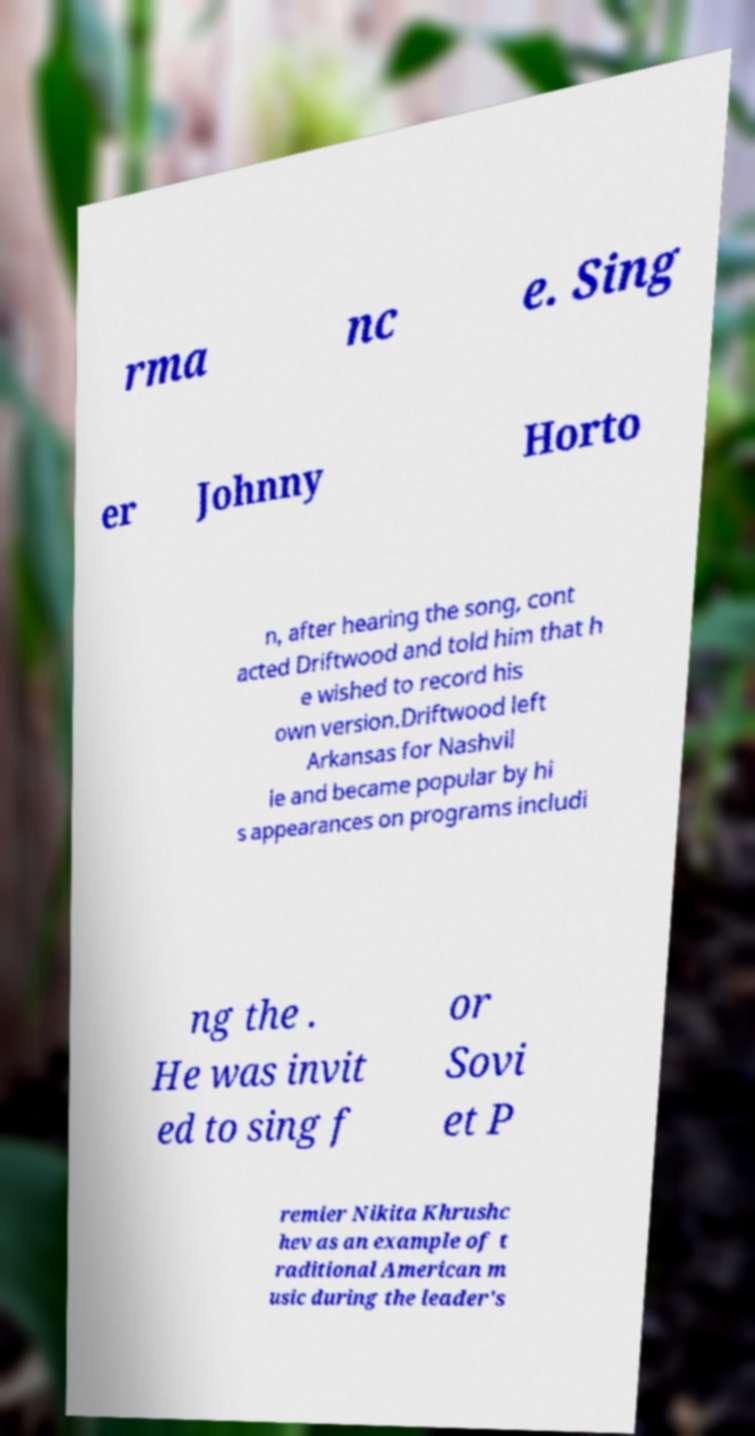What messages or text are displayed in this image? I need them in a readable, typed format. rma nc e. Sing er Johnny Horto n, after hearing the song, cont acted Driftwood and told him that h e wished to record his own version.Driftwood left Arkansas for Nashvil le and became popular by hi s appearances on programs includi ng the . He was invit ed to sing f or Sovi et P remier Nikita Khrushc hev as an example of t raditional American m usic during the leader's 